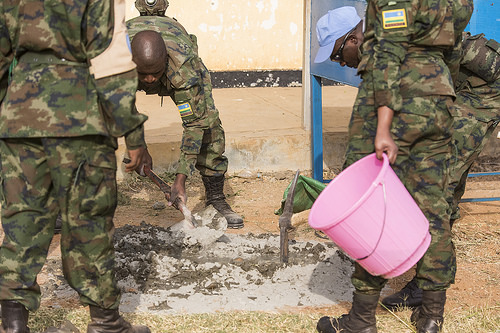<image>
Is there a bucket to the right of the man? Yes. From this viewpoint, the bucket is positioned to the right side relative to the man. 